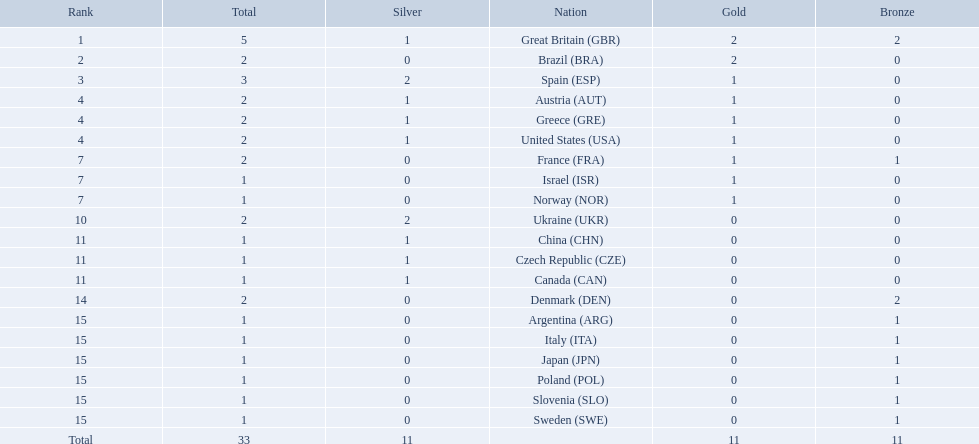What are all of the countries? Great Britain (GBR), Brazil (BRA), Spain (ESP), Austria (AUT), Greece (GRE), United States (USA), France (FRA), Israel (ISR), Norway (NOR), Ukraine (UKR), China (CHN), Czech Republic (CZE), Canada (CAN), Denmark (DEN), Argentina (ARG), Italy (ITA), Japan (JPN), Poland (POL), Slovenia (SLO), Sweden (SWE). Which ones earned a medal? Great Britain (GBR), Brazil (BRA), Spain (ESP), Austria (AUT), Greece (GRE), United States (USA), France (FRA), Israel (ISR), Norway (NOR), Ukraine (UKR), China (CHN), Czech Republic (CZE), Canada (CAN), Denmark (DEN), Argentina (ARG), Italy (ITA), Japan (JPN), Poland (POL), Slovenia (SLO), Sweden (SWE). Which countries earned at least 3 medals? Great Britain (GBR), Spain (ESP). Which country earned 3 medals? Spain (ESP). 